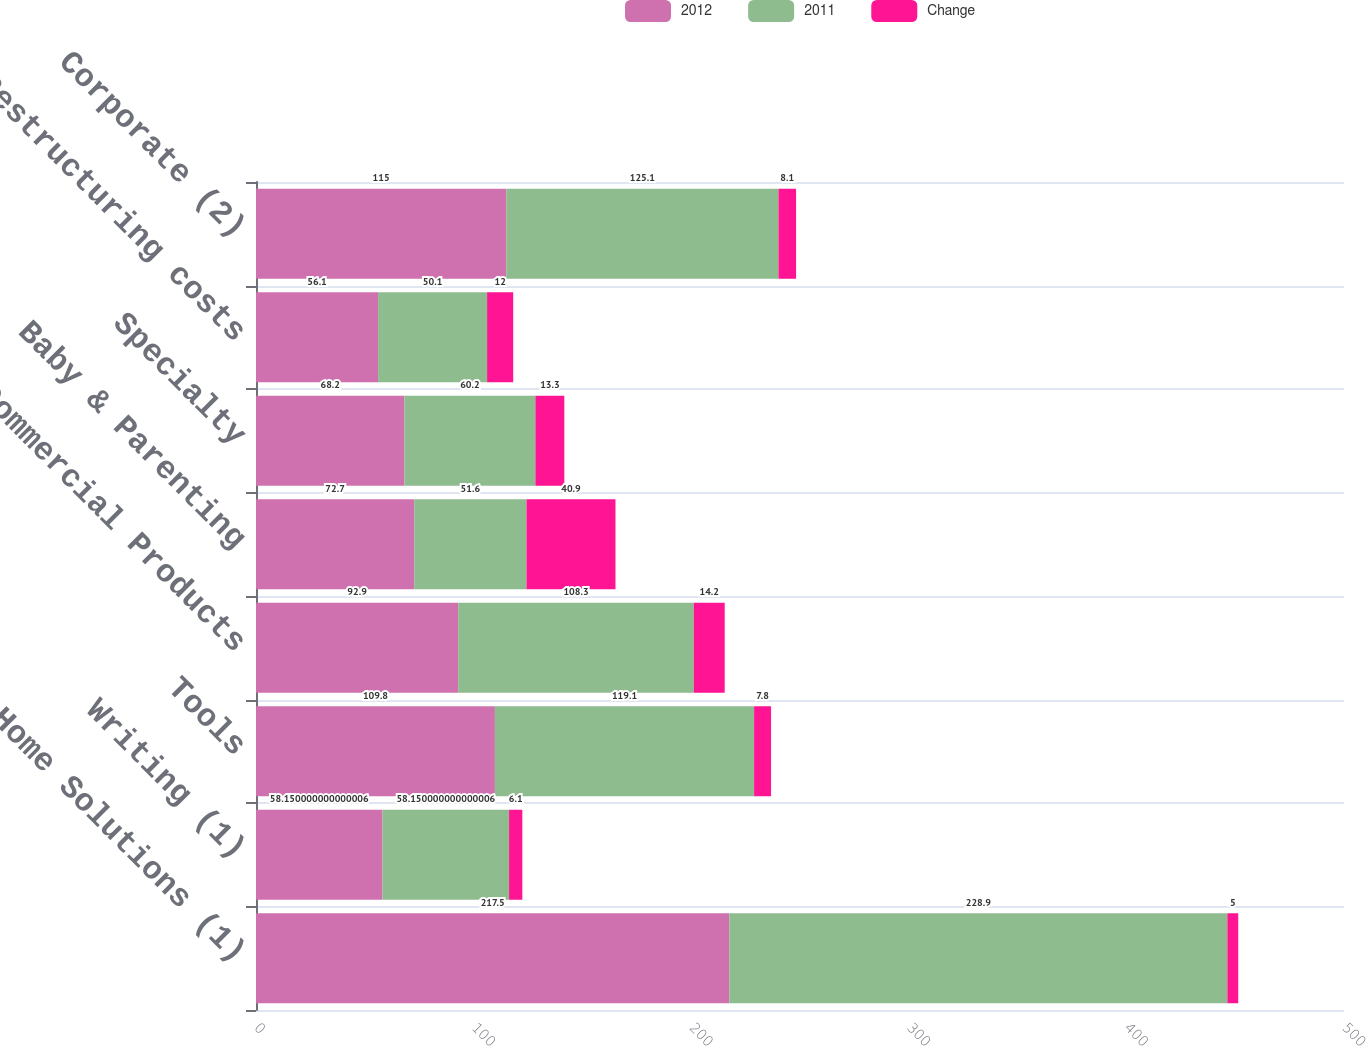Convert chart to OTSL. <chart><loc_0><loc_0><loc_500><loc_500><stacked_bar_chart><ecel><fcel>Home Solutions (1)<fcel>Writing (1)<fcel>Tools<fcel>Commercial Products<fcel>Baby & Parenting<fcel>Specialty<fcel>Restructuring costs<fcel>Corporate (2)<nl><fcel>2012<fcel>217.5<fcel>58.15<fcel>109.8<fcel>92.9<fcel>72.7<fcel>68.2<fcel>56.1<fcel>115<nl><fcel>2011<fcel>228.9<fcel>58.15<fcel>119.1<fcel>108.3<fcel>51.6<fcel>60.2<fcel>50.1<fcel>125.1<nl><fcel>Change<fcel>5<fcel>6.1<fcel>7.8<fcel>14.2<fcel>40.9<fcel>13.3<fcel>12<fcel>8.1<nl></chart> 